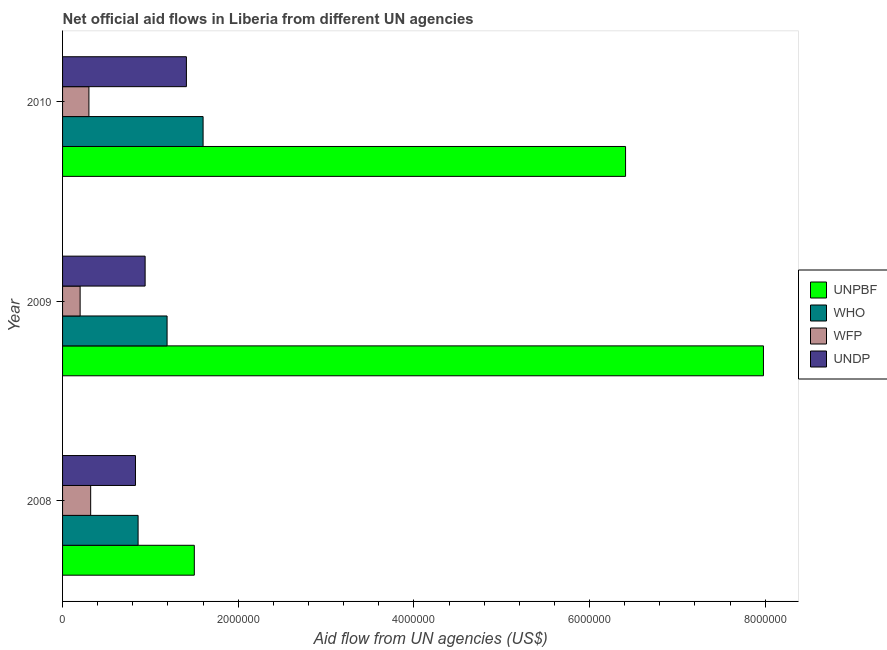How many different coloured bars are there?
Your answer should be compact. 4. How many bars are there on the 1st tick from the bottom?
Provide a succinct answer. 4. In how many cases, is the number of bars for a given year not equal to the number of legend labels?
Offer a very short reply. 0. What is the amount of aid given by unpbf in 2009?
Your answer should be compact. 7.98e+06. Across all years, what is the maximum amount of aid given by undp?
Make the answer very short. 1.41e+06. Across all years, what is the minimum amount of aid given by who?
Your answer should be very brief. 8.60e+05. What is the total amount of aid given by wfp in the graph?
Your response must be concise. 8.20e+05. What is the difference between the amount of aid given by wfp in 2008 and that in 2010?
Offer a very short reply. 2.00e+04. What is the difference between the amount of aid given by wfp in 2010 and the amount of aid given by unpbf in 2008?
Offer a terse response. -1.20e+06. What is the average amount of aid given by who per year?
Offer a very short reply. 1.22e+06. In the year 2008, what is the difference between the amount of aid given by wfp and amount of aid given by who?
Ensure brevity in your answer.  -5.40e+05. What is the ratio of the amount of aid given by undp in 2008 to that in 2010?
Provide a succinct answer. 0.59. Is the amount of aid given by wfp in 2008 less than that in 2009?
Offer a terse response. No. Is the difference between the amount of aid given by who in 2008 and 2009 greater than the difference between the amount of aid given by unpbf in 2008 and 2009?
Ensure brevity in your answer.  Yes. What is the difference between the highest and the second highest amount of aid given by unpbf?
Give a very brief answer. 1.57e+06. What is the difference between the highest and the lowest amount of aid given by undp?
Provide a succinct answer. 5.80e+05. Is it the case that in every year, the sum of the amount of aid given by who and amount of aid given by unpbf is greater than the sum of amount of aid given by undp and amount of aid given by wfp?
Your answer should be very brief. No. What does the 2nd bar from the top in 2008 represents?
Your response must be concise. WFP. What does the 4th bar from the bottom in 2008 represents?
Your response must be concise. UNDP. How many bars are there?
Offer a very short reply. 12. How many years are there in the graph?
Your response must be concise. 3. Are the values on the major ticks of X-axis written in scientific E-notation?
Your response must be concise. No. Does the graph contain any zero values?
Provide a short and direct response. No. Does the graph contain grids?
Ensure brevity in your answer.  No. Where does the legend appear in the graph?
Keep it short and to the point. Center right. How are the legend labels stacked?
Provide a succinct answer. Vertical. What is the title of the graph?
Your answer should be compact. Net official aid flows in Liberia from different UN agencies. What is the label or title of the X-axis?
Offer a very short reply. Aid flow from UN agencies (US$). What is the Aid flow from UN agencies (US$) in UNPBF in 2008?
Make the answer very short. 1.50e+06. What is the Aid flow from UN agencies (US$) of WHO in 2008?
Your answer should be very brief. 8.60e+05. What is the Aid flow from UN agencies (US$) of UNDP in 2008?
Your answer should be very brief. 8.30e+05. What is the Aid flow from UN agencies (US$) of UNPBF in 2009?
Give a very brief answer. 7.98e+06. What is the Aid flow from UN agencies (US$) in WHO in 2009?
Your answer should be compact. 1.19e+06. What is the Aid flow from UN agencies (US$) in UNDP in 2009?
Your response must be concise. 9.40e+05. What is the Aid flow from UN agencies (US$) in UNPBF in 2010?
Give a very brief answer. 6.41e+06. What is the Aid flow from UN agencies (US$) of WHO in 2010?
Ensure brevity in your answer.  1.60e+06. What is the Aid flow from UN agencies (US$) in WFP in 2010?
Your answer should be very brief. 3.00e+05. What is the Aid flow from UN agencies (US$) of UNDP in 2010?
Offer a very short reply. 1.41e+06. Across all years, what is the maximum Aid flow from UN agencies (US$) of UNPBF?
Provide a succinct answer. 7.98e+06. Across all years, what is the maximum Aid flow from UN agencies (US$) in WHO?
Make the answer very short. 1.60e+06. Across all years, what is the maximum Aid flow from UN agencies (US$) in WFP?
Ensure brevity in your answer.  3.20e+05. Across all years, what is the maximum Aid flow from UN agencies (US$) in UNDP?
Ensure brevity in your answer.  1.41e+06. Across all years, what is the minimum Aid flow from UN agencies (US$) of UNPBF?
Your answer should be compact. 1.50e+06. Across all years, what is the minimum Aid flow from UN agencies (US$) of WHO?
Offer a terse response. 8.60e+05. Across all years, what is the minimum Aid flow from UN agencies (US$) in WFP?
Your answer should be compact. 2.00e+05. Across all years, what is the minimum Aid flow from UN agencies (US$) of UNDP?
Your answer should be compact. 8.30e+05. What is the total Aid flow from UN agencies (US$) in UNPBF in the graph?
Provide a succinct answer. 1.59e+07. What is the total Aid flow from UN agencies (US$) of WHO in the graph?
Give a very brief answer. 3.65e+06. What is the total Aid flow from UN agencies (US$) in WFP in the graph?
Make the answer very short. 8.20e+05. What is the total Aid flow from UN agencies (US$) of UNDP in the graph?
Give a very brief answer. 3.18e+06. What is the difference between the Aid flow from UN agencies (US$) in UNPBF in 2008 and that in 2009?
Keep it short and to the point. -6.48e+06. What is the difference between the Aid flow from UN agencies (US$) of WHO in 2008 and that in 2009?
Provide a succinct answer. -3.30e+05. What is the difference between the Aid flow from UN agencies (US$) in WFP in 2008 and that in 2009?
Your response must be concise. 1.20e+05. What is the difference between the Aid flow from UN agencies (US$) of UNDP in 2008 and that in 2009?
Your response must be concise. -1.10e+05. What is the difference between the Aid flow from UN agencies (US$) of UNPBF in 2008 and that in 2010?
Keep it short and to the point. -4.91e+06. What is the difference between the Aid flow from UN agencies (US$) of WHO in 2008 and that in 2010?
Your response must be concise. -7.40e+05. What is the difference between the Aid flow from UN agencies (US$) of WFP in 2008 and that in 2010?
Offer a terse response. 2.00e+04. What is the difference between the Aid flow from UN agencies (US$) in UNDP in 2008 and that in 2010?
Ensure brevity in your answer.  -5.80e+05. What is the difference between the Aid flow from UN agencies (US$) in UNPBF in 2009 and that in 2010?
Offer a terse response. 1.57e+06. What is the difference between the Aid flow from UN agencies (US$) of WHO in 2009 and that in 2010?
Your answer should be compact. -4.10e+05. What is the difference between the Aid flow from UN agencies (US$) of UNDP in 2009 and that in 2010?
Your response must be concise. -4.70e+05. What is the difference between the Aid flow from UN agencies (US$) of UNPBF in 2008 and the Aid flow from UN agencies (US$) of WFP in 2009?
Keep it short and to the point. 1.30e+06. What is the difference between the Aid flow from UN agencies (US$) of UNPBF in 2008 and the Aid flow from UN agencies (US$) of UNDP in 2009?
Offer a terse response. 5.60e+05. What is the difference between the Aid flow from UN agencies (US$) in WHO in 2008 and the Aid flow from UN agencies (US$) in WFP in 2009?
Provide a succinct answer. 6.60e+05. What is the difference between the Aid flow from UN agencies (US$) of WHO in 2008 and the Aid flow from UN agencies (US$) of UNDP in 2009?
Your response must be concise. -8.00e+04. What is the difference between the Aid flow from UN agencies (US$) in WFP in 2008 and the Aid flow from UN agencies (US$) in UNDP in 2009?
Provide a succinct answer. -6.20e+05. What is the difference between the Aid flow from UN agencies (US$) of UNPBF in 2008 and the Aid flow from UN agencies (US$) of WFP in 2010?
Ensure brevity in your answer.  1.20e+06. What is the difference between the Aid flow from UN agencies (US$) in UNPBF in 2008 and the Aid flow from UN agencies (US$) in UNDP in 2010?
Provide a succinct answer. 9.00e+04. What is the difference between the Aid flow from UN agencies (US$) of WHO in 2008 and the Aid flow from UN agencies (US$) of WFP in 2010?
Your answer should be compact. 5.60e+05. What is the difference between the Aid flow from UN agencies (US$) of WHO in 2008 and the Aid flow from UN agencies (US$) of UNDP in 2010?
Your response must be concise. -5.50e+05. What is the difference between the Aid flow from UN agencies (US$) of WFP in 2008 and the Aid flow from UN agencies (US$) of UNDP in 2010?
Your response must be concise. -1.09e+06. What is the difference between the Aid flow from UN agencies (US$) in UNPBF in 2009 and the Aid flow from UN agencies (US$) in WHO in 2010?
Make the answer very short. 6.38e+06. What is the difference between the Aid flow from UN agencies (US$) in UNPBF in 2009 and the Aid flow from UN agencies (US$) in WFP in 2010?
Your answer should be very brief. 7.68e+06. What is the difference between the Aid flow from UN agencies (US$) in UNPBF in 2009 and the Aid flow from UN agencies (US$) in UNDP in 2010?
Provide a short and direct response. 6.57e+06. What is the difference between the Aid flow from UN agencies (US$) in WHO in 2009 and the Aid flow from UN agencies (US$) in WFP in 2010?
Offer a terse response. 8.90e+05. What is the difference between the Aid flow from UN agencies (US$) of WHO in 2009 and the Aid flow from UN agencies (US$) of UNDP in 2010?
Make the answer very short. -2.20e+05. What is the difference between the Aid flow from UN agencies (US$) in WFP in 2009 and the Aid flow from UN agencies (US$) in UNDP in 2010?
Offer a very short reply. -1.21e+06. What is the average Aid flow from UN agencies (US$) of UNPBF per year?
Offer a terse response. 5.30e+06. What is the average Aid flow from UN agencies (US$) of WHO per year?
Your answer should be compact. 1.22e+06. What is the average Aid flow from UN agencies (US$) of WFP per year?
Keep it short and to the point. 2.73e+05. What is the average Aid flow from UN agencies (US$) of UNDP per year?
Offer a very short reply. 1.06e+06. In the year 2008, what is the difference between the Aid flow from UN agencies (US$) in UNPBF and Aid flow from UN agencies (US$) in WHO?
Your answer should be very brief. 6.40e+05. In the year 2008, what is the difference between the Aid flow from UN agencies (US$) of UNPBF and Aid flow from UN agencies (US$) of WFP?
Your response must be concise. 1.18e+06. In the year 2008, what is the difference between the Aid flow from UN agencies (US$) in UNPBF and Aid flow from UN agencies (US$) in UNDP?
Provide a succinct answer. 6.70e+05. In the year 2008, what is the difference between the Aid flow from UN agencies (US$) in WHO and Aid flow from UN agencies (US$) in WFP?
Your answer should be very brief. 5.40e+05. In the year 2008, what is the difference between the Aid flow from UN agencies (US$) of WHO and Aid flow from UN agencies (US$) of UNDP?
Provide a succinct answer. 3.00e+04. In the year 2008, what is the difference between the Aid flow from UN agencies (US$) in WFP and Aid flow from UN agencies (US$) in UNDP?
Provide a succinct answer. -5.10e+05. In the year 2009, what is the difference between the Aid flow from UN agencies (US$) of UNPBF and Aid flow from UN agencies (US$) of WHO?
Make the answer very short. 6.79e+06. In the year 2009, what is the difference between the Aid flow from UN agencies (US$) in UNPBF and Aid flow from UN agencies (US$) in WFP?
Provide a succinct answer. 7.78e+06. In the year 2009, what is the difference between the Aid flow from UN agencies (US$) of UNPBF and Aid flow from UN agencies (US$) of UNDP?
Make the answer very short. 7.04e+06. In the year 2009, what is the difference between the Aid flow from UN agencies (US$) of WHO and Aid flow from UN agencies (US$) of WFP?
Provide a succinct answer. 9.90e+05. In the year 2009, what is the difference between the Aid flow from UN agencies (US$) in WHO and Aid flow from UN agencies (US$) in UNDP?
Keep it short and to the point. 2.50e+05. In the year 2009, what is the difference between the Aid flow from UN agencies (US$) in WFP and Aid flow from UN agencies (US$) in UNDP?
Provide a short and direct response. -7.40e+05. In the year 2010, what is the difference between the Aid flow from UN agencies (US$) in UNPBF and Aid flow from UN agencies (US$) in WHO?
Offer a terse response. 4.81e+06. In the year 2010, what is the difference between the Aid flow from UN agencies (US$) of UNPBF and Aid flow from UN agencies (US$) of WFP?
Your response must be concise. 6.11e+06. In the year 2010, what is the difference between the Aid flow from UN agencies (US$) of WHO and Aid flow from UN agencies (US$) of WFP?
Offer a very short reply. 1.30e+06. In the year 2010, what is the difference between the Aid flow from UN agencies (US$) of WHO and Aid flow from UN agencies (US$) of UNDP?
Make the answer very short. 1.90e+05. In the year 2010, what is the difference between the Aid flow from UN agencies (US$) in WFP and Aid flow from UN agencies (US$) in UNDP?
Ensure brevity in your answer.  -1.11e+06. What is the ratio of the Aid flow from UN agencies (US$) of UNPBF in 2008 to that in 2009?
Make the answer very short. 0.19. What is the ratio of the Aid flow from UN agencies (US$) of WHO in 2008 to that in 2009?
Provide a short and direct response. 0.72. What is the ratio of the Aid flow from UN agencies (US$) of UNDP in 2008 to that in 2009?
Offer a terse response. 0.88. What is the ratio of the Aid flow from UN agencies (US$) in UNPBF in 2008 to that in 2010?
Make the answer very short. 0.23. What is the ratio of the Aid flow from UN agencies (US$) in WHO in 2008 to that in 2010?
Your response must be concise. 0.54. What is the ratio of the Aid flow from UN agencies (US$) in WFP in 2008 to that in 2010?
Your answer should be compact. 1.07. What is the ratio of the Aid flow from UN agencies (US$) in UNDP in 2008 to that in 2010?
Provide a short and direct response. 0.59. What is the ratio of the Aid flow from UN agencies (US$) in UNPBF in 2009 to that in 2010?
Provide a succinct answer. 1.24. What is the ratio of the Aid flow from UN agencies (US$) of WHO in 2009 to that in 2010?
Give a very brief answer. 0.74. What is the ratio of the Aid flow from UN agencies (US$) of WFP in 2009 to that in 2010?
Give a very brief answer. 0.67. What is the difference between the highest and the second highest Aid flow from UN agencies (US$) of UNPBF?
Your answer should be compact. 1.57e+06. What is the difference between the highest and the second highest Aid flow from UN agencies (US$) in WHO?
Keep it short and to the point. 4.10e+05. What is the difference between the highest and the second highest Aid flow from UN agencies (US$) in UNDP?
Offer a very short reply. 4.70e+05. What is the difference between the highest and the lowest Aid flow from UN agencies (US$) of UNPBF?
Your answer should be compact. 6.48e+06. What is the difference between the highest and the lowest Aid flow from UN agencies (US$) in WHO?
Your answer should be very brief. 7.40e+05. What is the difference between the highest and the lowest Aid flow from UN agencies (US$) of WFP?
Make the answer very short. 1.20e+05. What is the difference between the highest and the lowest Aid flow from UN agencies (US$) in UNDP?
Give a very brief answer. 5.80e+05. 